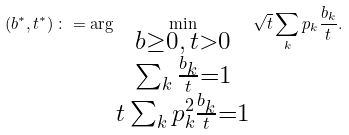<formula> <loc_0><loc_0><loc_500><loc_500>\left ( b ^ { * } , t ^ { * } \right ) \colon = \arg \min _ { \substack { b \geq 0 , \, t > 0 \\ \sum _ { k } \frac { b _ { k } } t = 1 \\ t \sum _ { k } p _ { k } ^ { 2 } \frac { b _ { k } } t = 1 } } \sqrt { t } \sum _ { k } p _ { k } \frac { b _ { k } } t .</formula> 